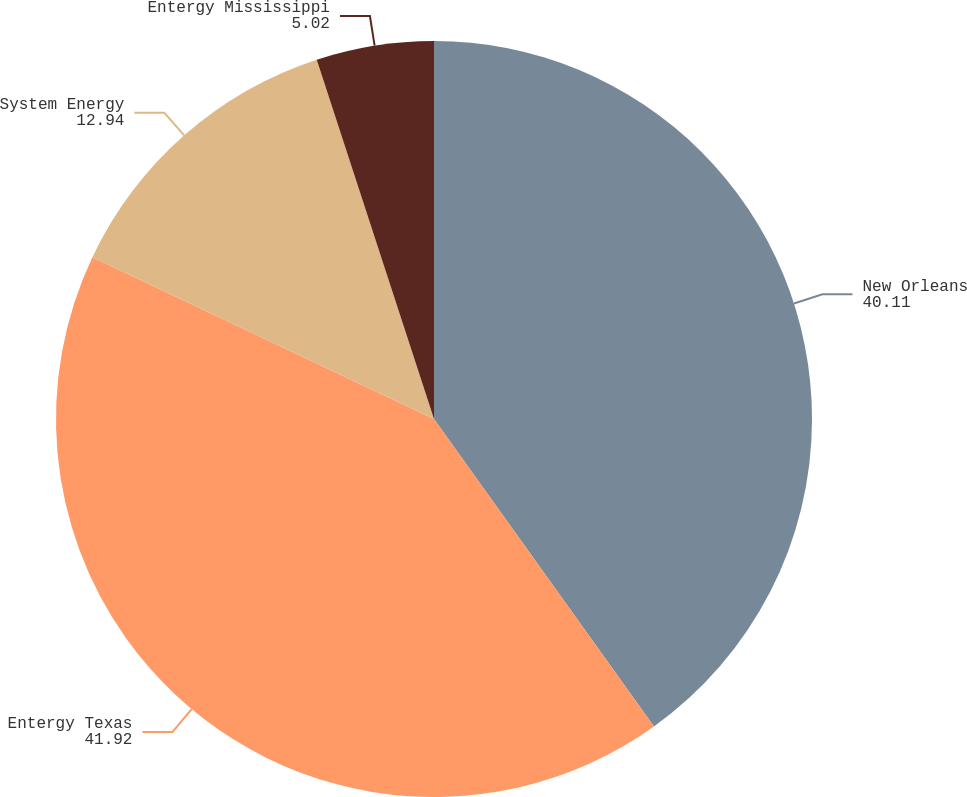<chart> <loc_0><loc_0><loc_500><loc_500><pie_chart><fcel>New Orleans<fcel>Entergy Texas<fcel>System Energy<fcel>Entergy Mississippi<nl><fcel>40.11%<fcel>41.92%<fcel>12.94%<fcel>5.02%<nl></chart> 